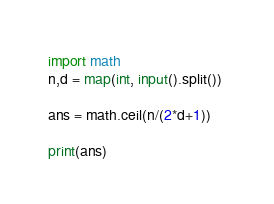Convert code to text. <code><loc_0><loc_0><loc_500><loc_500><_Python_>import math
n,d = map(int, input().split()) 

ans = math.ceil(n/(2*d+1))

print(ans)</code> 